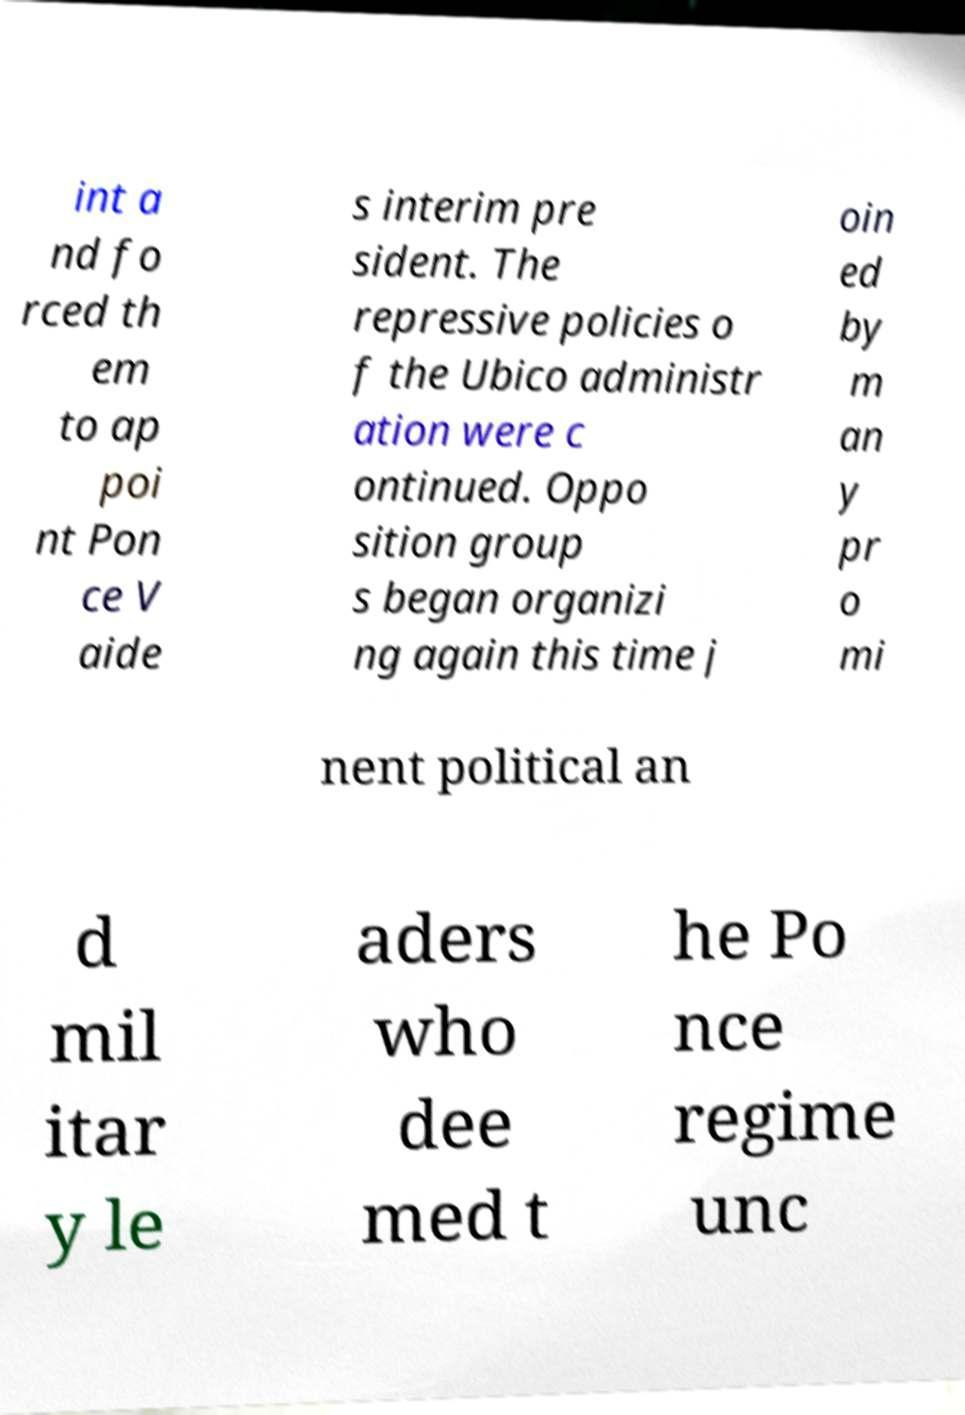What messages or text are displayed in this image? I need them in a readable, typed format. int a nd fo rced th em to ap poi nt Pon ce V aide s interim pre sident. The repressive policies o f the Ubico administr ation were c ontinued. Oppo sition group s began organizi ng again this time j oin ed by m an y pr o mi nent political an d mil itar y le aders who dee med t he Po nce regime unc 